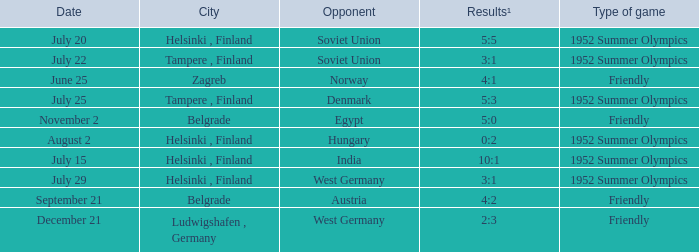With the Type is game of friendly and the City Belgrade and November 2 as the Date what were the Results¹? 5:0. 